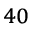<formula> <loc_0><loc_0><loc_500><loc_500>^ { 4 0 }</formula> 